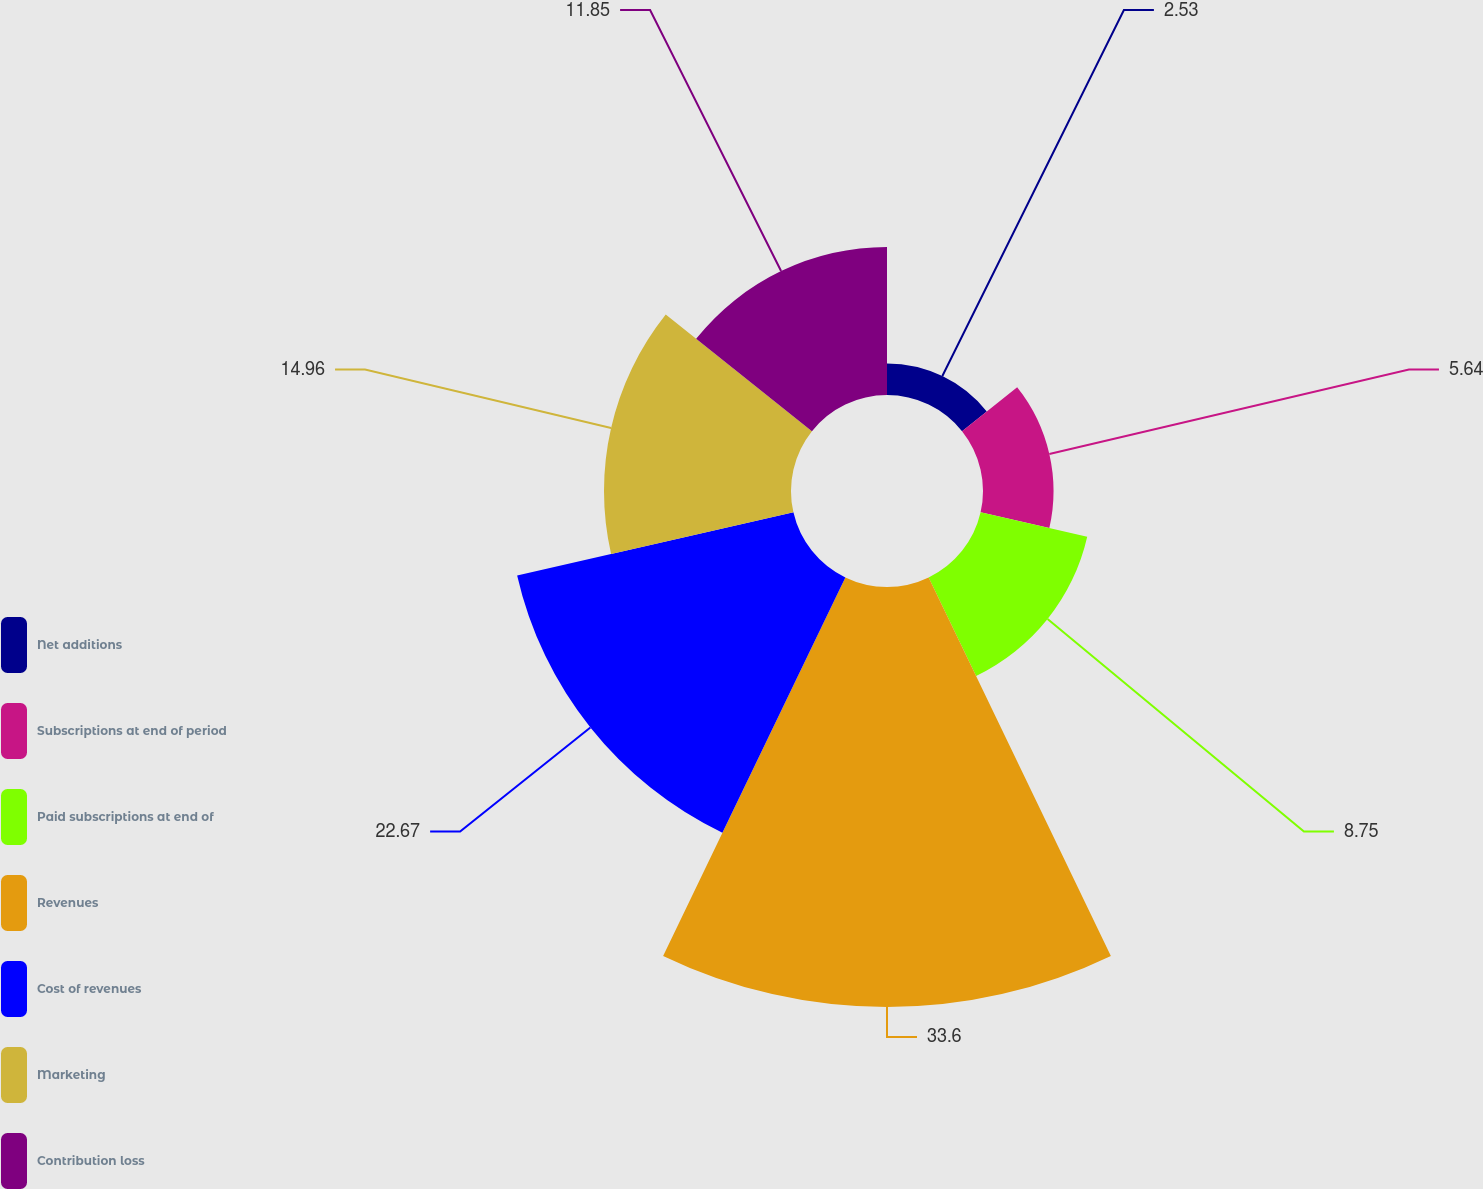Convert chart to OTSL. <chart><loc_0><loc_0><loc_500><loc_500><pie_chart><fcel>Net additions<fcel>Subscriptions at end of period<fcel>Paid subscriptions at end of<fcel>Revenues<fcel>Cost of revenues<fcel>Marketing<fcel>Contribution loss<nl><fcel>2.53%<fcel>5.64%<fcel>8.75%<fcel>33.6%<fcel>22.67%<fcel>14.96%<fcel>11.85%<nl></chart> 